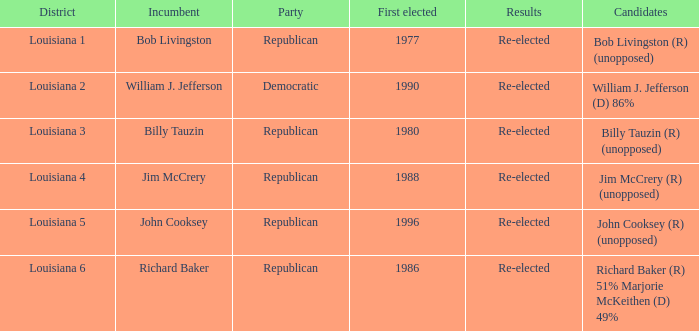What political party is william j. jefferson a member of? Democratic. 